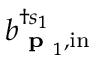<formula> <loc_0><loc_0><loc_500><loc_500>b _ { { p } _ { 1 } , i n } ^ { \dagger s _ { 1 } }</formula> 